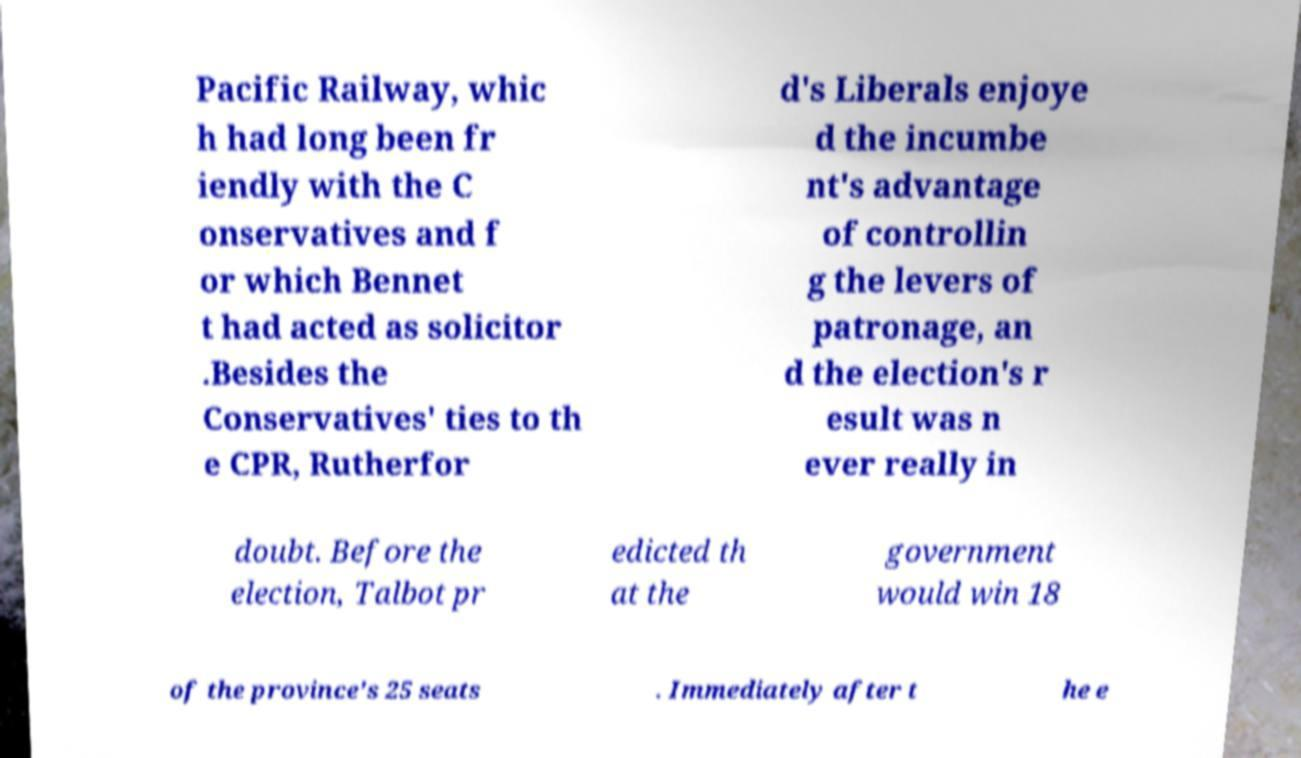Can you accurately transcribe the text from the provided image for me? Pacific Railway, whic h had long been fr iendly with the C onservatives and f or which Bennet t had acted as solicitor .Besides the Conservatives' ties to th e CPR, Rutherfor d's Liberals enjoye d the incumbe nt's advantage of controllin g the levers of patronage, an d the election's r esult was n ever really in doubt. Before the election, Talbot pr edicted th at the government would win 18 of the province's 25 seats . Immediately after t he e 